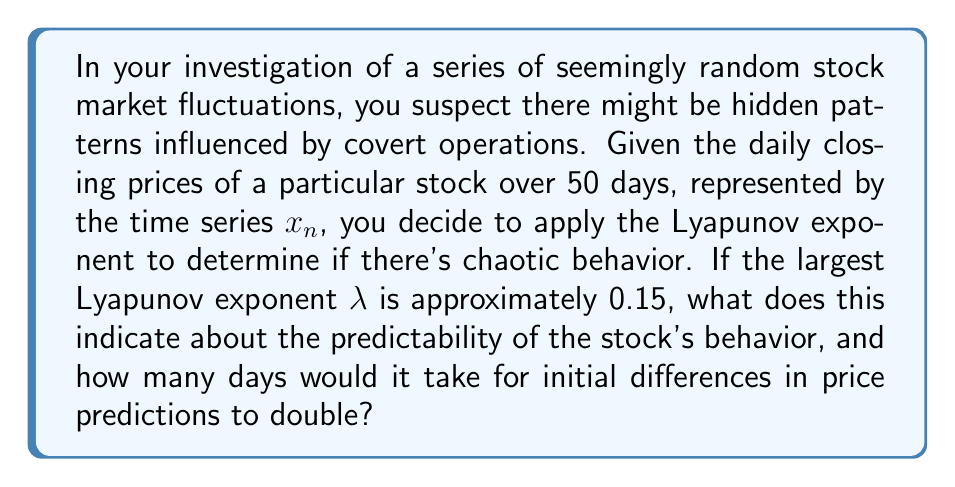Solve this math problem. To analyze this situation, let's break it down step-by-step:

1) The Lyapunov exponent ($\lambda$) measures the rate of separation of infinitesimally close trajectories in a dynamical system. In this case, it represents how quickly small differences in initial stock price predictions would grow over time.

2) A positive Lyapunov exponent indicates chaotic behavior. The larger the value, the more chaotic the system.

3) Given $\lambda \approx 0.15$, we can confirm that the system exhibits chaotic behavior, as the exponent is positive.

4) To calculate the time it takes for initial differences to double, we use the formula:

   $$T_2 = \frac{\ln(2)}{\lambda}$$

   Where $T_2$ is the doubling time and $\ln$ is the natural logarithm.

5) Substituting the given value:

   $$T_2 = \frac{\ln(2)}{0.15} \approx 4.62$$

6) Since we're dealing with daily closing prices, we round up to the nearest whole number of days.

This result indicates that small differences in initial predictions would double approximately every 5 days, suggesting a highly unpredictable and potentially manipulated market behavior.
Answer: Chaotic behavior; 5 days 